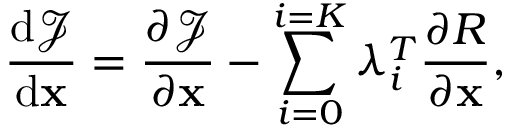Convert formula to latex. <formula><loc_0><loc_0><loc_500><loc_500>\frac { d \mathcal { J } } { d { x } } = { \frac { \partial \mathcal { J } } { \partial { x } } } - \sum _ { i = 0 } ^ { i = K } \lambda _ { i } ^ { T } { \frac { \partial R } { \partial { x } } } ,</formula> 